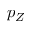Convert formula to latex. <formula><loc_0><loc_0><loc_500><loc_500>p _ { Z }</formula> 